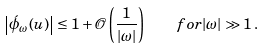<formula> <loc_0><loc_0><loc_500><loc_500>\left | \acute { \phi } _ { \omega } ( u ) \right | \leq 1 + \mathcal { O } \left ( \frac { 1 } { | \omega | } \right ) \quad f o r | \omega | \gg 1 \, .</formula> 